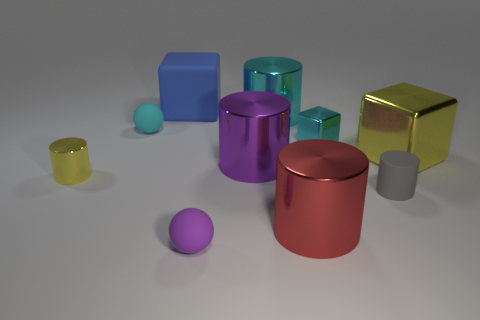Does the small metallic thing that is to the right of the purple shiny cylinder have the same shape as the yellow metal thing on the left side of the tiny cyan matte thing?
Provide a succinct answer. No. Are there any big cyan things made of the same material as the gray object?
Your response must be concise. No. What color is the metal cylinder behind the cyan thing on the left side of the ball in front of the tiny metal cylinder?
Provide a short and direct response. Cyan. Do the tiny ball that is behind the yellow cylinder and the yellow thing to the left of the gray object have the same material?
Keep it short and to the point. No. There is a purple object that is to the right of the purple rubber sphere; what shape is it?
Your answer should be compact. Cylinder. How many objects are big green objects or yellow metallic things on the right side of the small metal cylinder?
Ensure brevity in your answer.  1. Is the material of the small purple ball the same as the big red object?
Your response must be concise. No. Are there an equal number of tiny cyan shiny objects that are to the left of the large rubber thing and gray matte cylinders to the left of the purple ball?
Offer a very short reply. Yes. How many small cyan rubber objects are right of the large cyan thing?
Provide a short and direct response. 0. How many objects are large rubber cylinders or big blue blocks?
Ensure brevity in your answer.  1. 